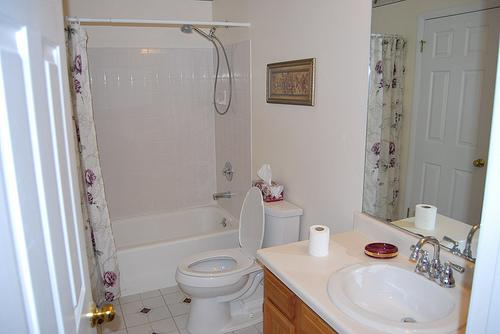Briefly describe the mirror and what it reflects. There is a large rectangular mirror on the wall that reflects the bathroom door and a flower print shower curtain. Describe the shower curtain in the image. The shower curtain has a patterned white design and a purple flower print. In a few words, describe the overall condition of the bathroom. Clean home restroom with various decorations and accessories. What are the materials and colors of the faucets in the bathroom? The faucets are silver and made of metal. Describe something unusual about the way the toilet paper is stored in this bathroom. The toilet paper is not on a holder; instead, it sits comfortably on the side of the sink. Name a few objects you can find in the bathroom. Toilet seat, tissue box, shower head, home decor, soap dish, bathroom floor tile, and faucet. What kind of curtain can you see in the reflection? A white flower curtain with purple roses. Explain the current state of the toilet and its surrounding area. The ceramic white toilet bowl has the seat left open, and there is a decorative box of tissue paper on the commode behind it. What type of floor do you see in the bathroom? Decorative bathroom floor tile with diamonds in the center. 